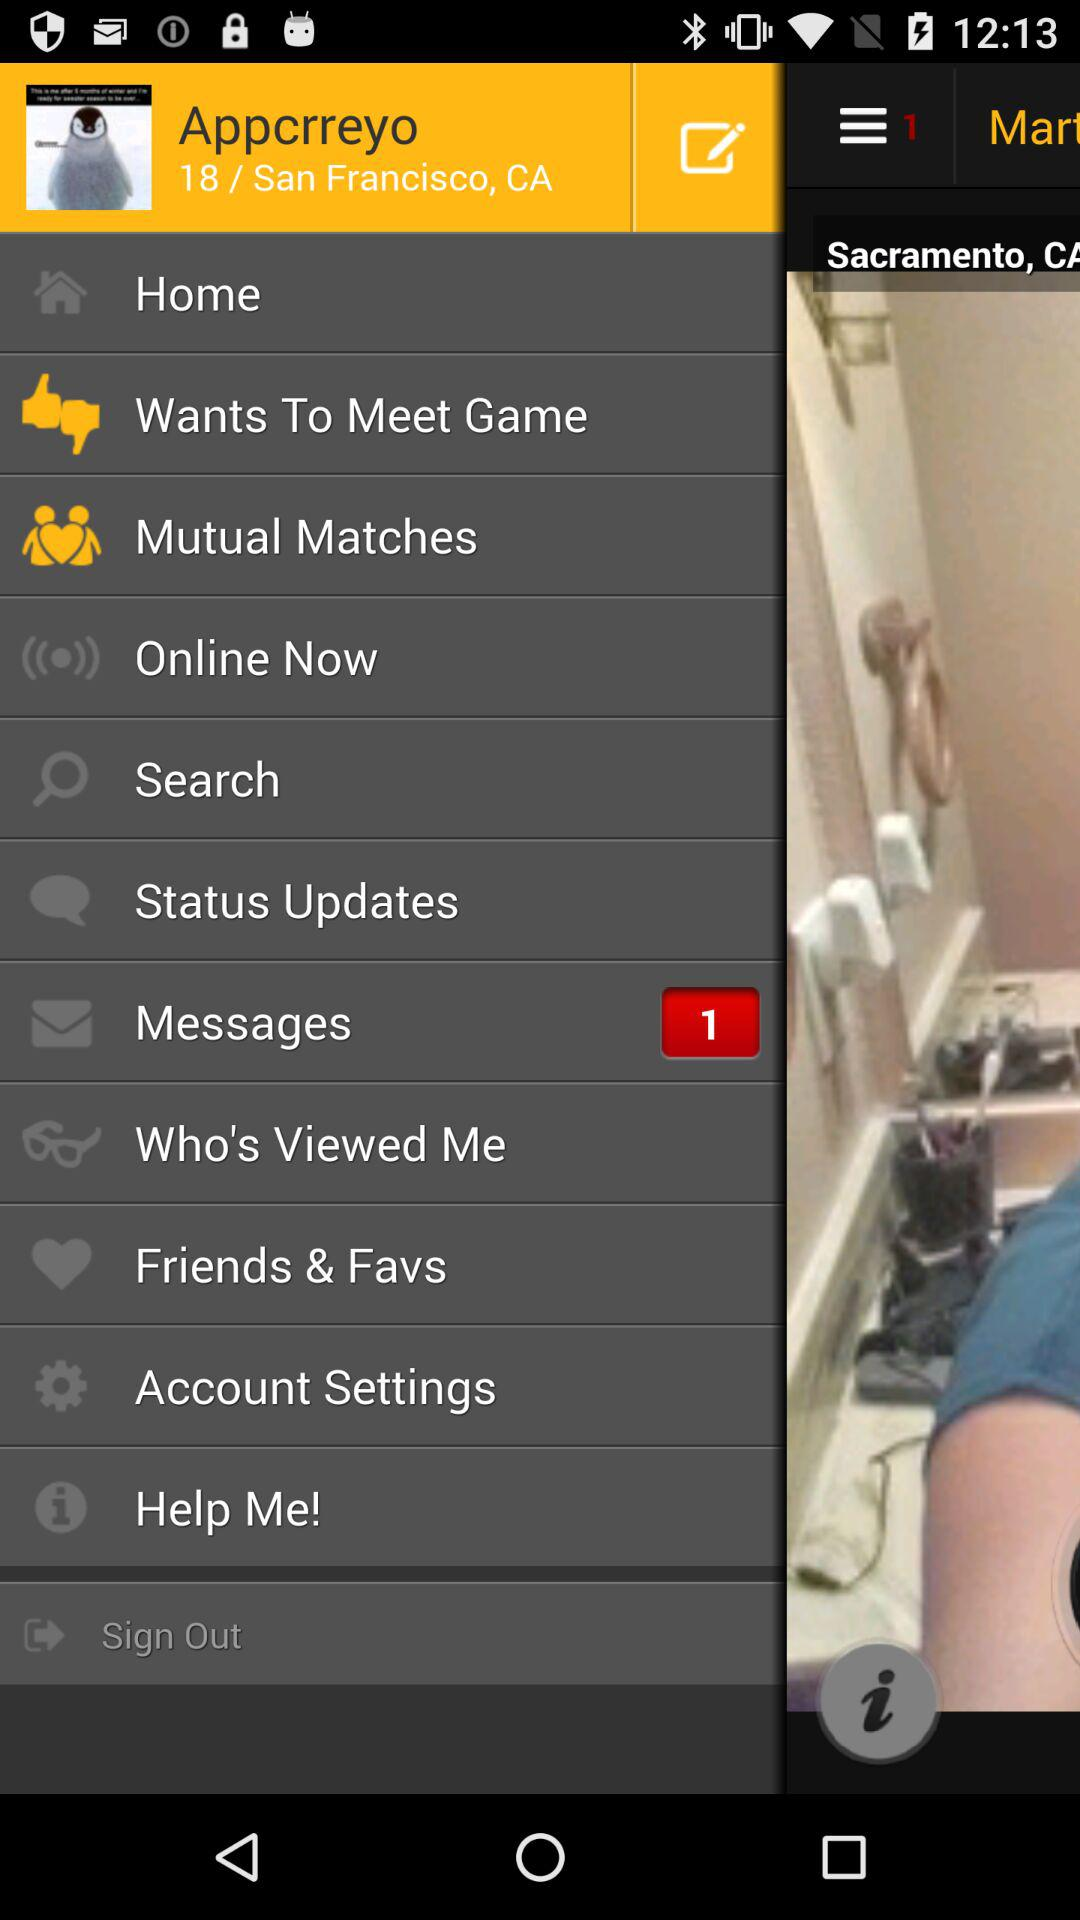What is the age of the user? The age of the user is 18 years. 